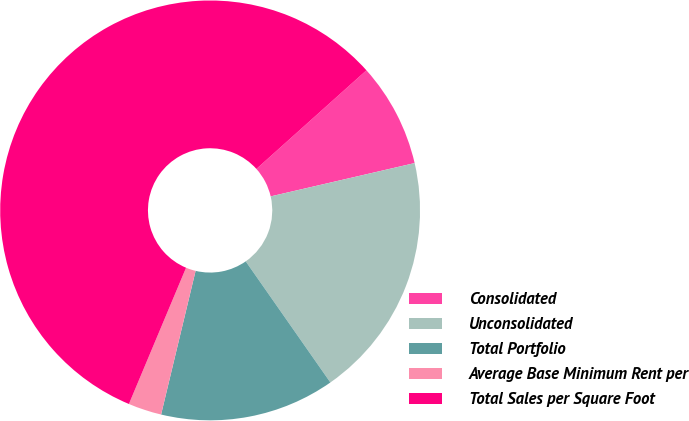Convert chart. <chart><loc_0><loc_0><loc_500><loc_500><pie_chart><fcel>Consolidated<fcel>Unconsolidated<fcel>Total Portfolio<fcel>Average Base Minimum Rent per<fcel>Total Sales per Square Foot<nl><fcel>8.01%<fcel>18.91%<fcel>13.46%<fcel>2.57%<fcel>57.05%<nl></chart> 